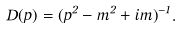Convert formula to latex. <formula><loc_0><loc_0><loc_500><loc_500>D ( p ) = ( p ^ { 2 } - m ^ { 2 } + i m \Gamma ) ^ { - 1 } .</formula> 